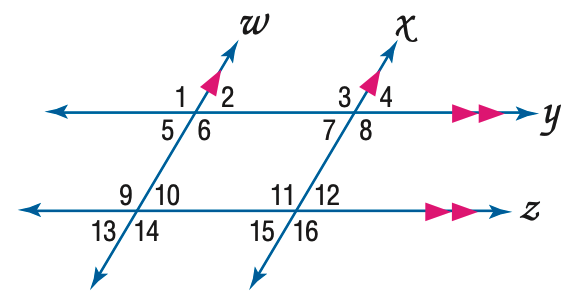Answer the mathemtical geometry problem and directly provide the correct option letter.
Question: In the figure, m \angle 12 = 64. Find the measure of \angle 5.
Choices: A: 54 B: 56 C: 64 D: 66 C 